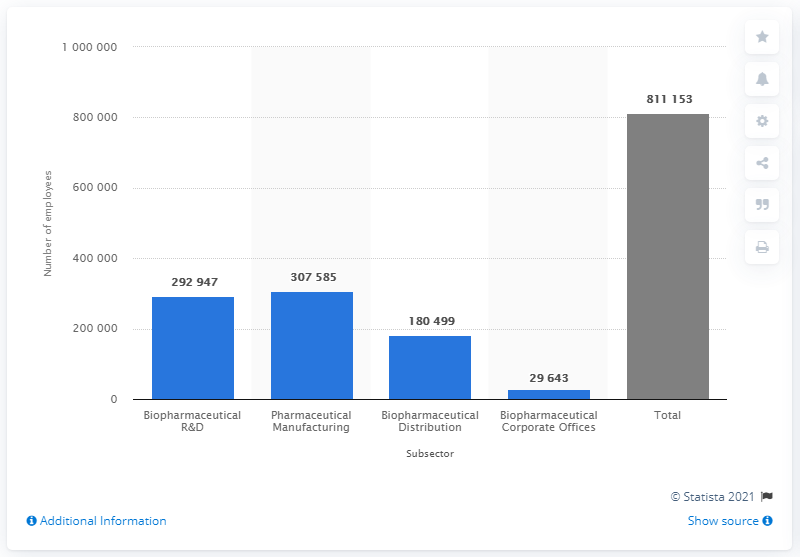Point out several critical features in this image. In 2017, the biopharmaceutical industry employed 292,947 individuals in research and development. 